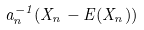<formula> <loc_0><loc_0><loc_500><loc_500>a _ { n } ^ { - 1 } ( X _ { n } - E ( X _ { n } ) )</formula> 